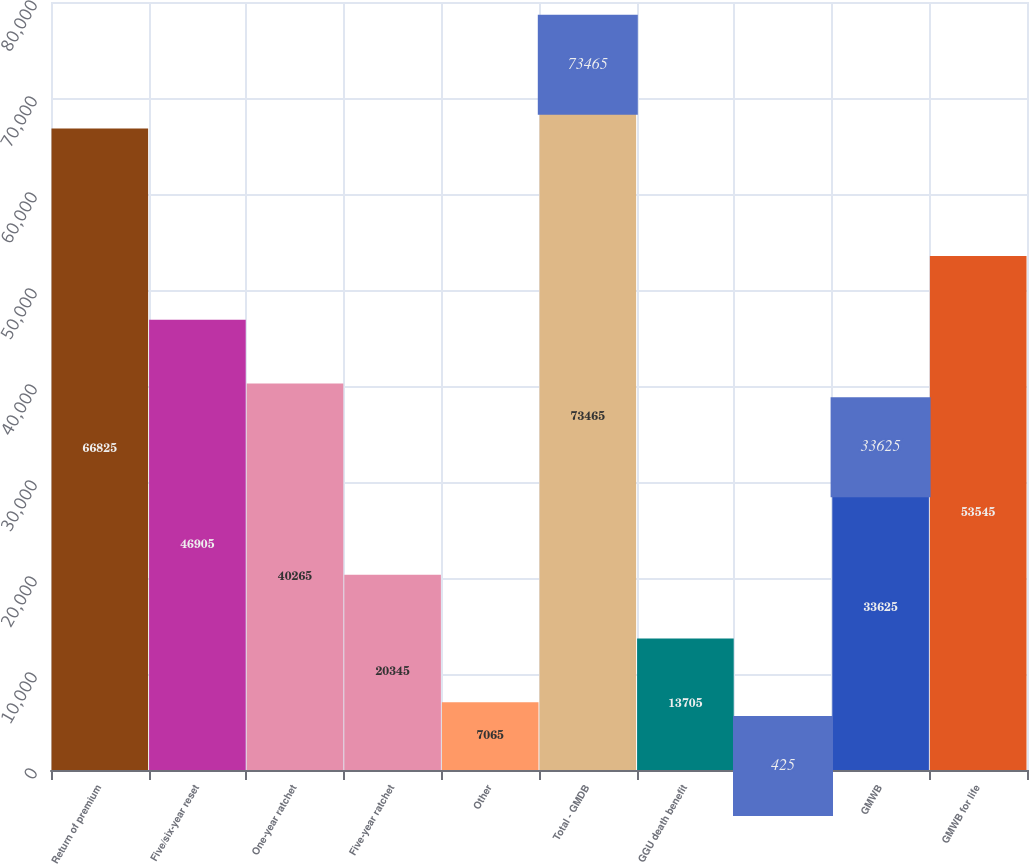<chart> <loc_0><loc_0><loc_500><loc_500><bar_chart><fcel>Return of premium<fcel>Five/six-year reset<fcel>One-year ratchet<fcel>Five-year ratchet<fcel>Other<fcel>Total - GMDB<fcel>GGU death benefit<fcel>GMIB<fcel>GMWB<fcel>GMWB for life<nl><fcel>66825<fcel>46905<fcel>40265<fcel>20345<fcel>7065<fcel>73465<fcel>13705<fcel>425<fcel>33625<fcel>53545<nl></chart> 